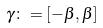Convert formula to latex. <formula><loc_0><loc_0><loc_500><loc_500>\gamma \colon = [ - \beta , \beta ]</formula> 